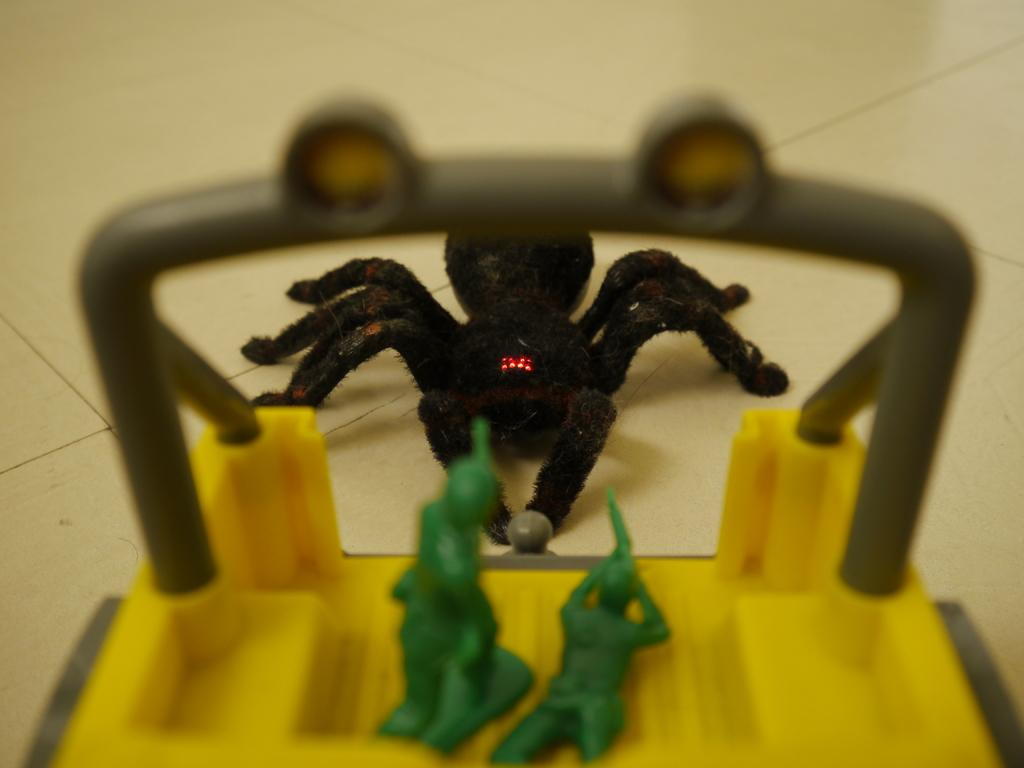What objects are present in the image? There are toys in the image. Where are the toys located? The toys are on the floor. Can you describe the positioning of the toys in the image? The toys are located in the center of the image. What type of crime is being committed in the image? There is no crime being committed in the image; it features toys on the floor. Can you describe the attack that is happening in the image? There is no attack happening in the image; it features toys on the floor. 